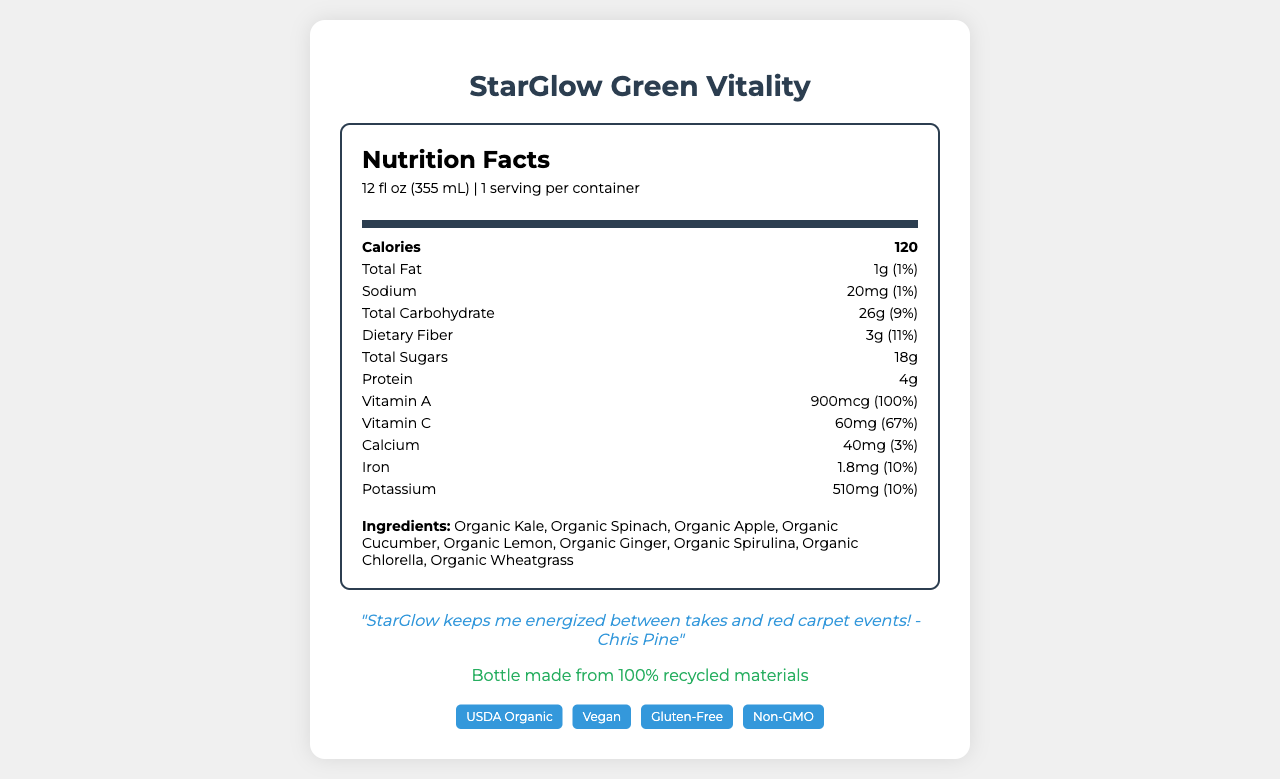how many calories are in one serving of StarGlow Green Vitality? The nutrition facts label lists the number of calories as 120 under the section for calories.
Answer: 120 calories what is the serving size of StarGlow Green Vitality? The serving size is indicated as "12 fl oz (355 mL)" above the calories section on the nutrition facts label.
Answer: 12 fl oz (355 mL) List three ingredients found in StarGlow Green Vitality. The ingredients are listed towards the bottom of the nutrition facts label, starting with Organic Kale, Organic Spinach, and Organic Apple.
Answer: Organic Kale, Organic Spinach, Organic Apple what percentage of daily vitamin C does StarGlow Green Vitality provide? The nutrition facts label shows that the juice provides 67% of the daily value of vitamin C.
Answer: 67% how much sodium is in one serving of StarGlow Green Vitality? The amount of sodium per serving is listed as 20mg on the nutrition facts label.
Answer: 20mg what is the dietary fiber content in StarGlow Green Vitality? The nutrition facts label indicates that there is 3 grams of dietary fiber in one serving.
Answer: 3g how many grams of protein are in StarGlow Green Vitality? The label states that the juice contains 4 grams of protein per serving.
Answer: 4g Which of the following certifications does StarGlow Green Vitality have? A. USDA Organic B. Fair Trade C. Halal The label includes a "USDA Organic" certification.
Answer: A. USDA Organic What is the daily value percentage of potassium in StarGlow Green Vitality? A. 5% B. 10% C. 15% D. 20% The label states that the daily value percentage of potassium is 10%.
Answer: B. 10% Is StarGlow Green Vitality vegan? The document mentions that the product is vegan, which is indicated in the certifications and labeled on the packaging.
Answer: Yes Summarize the main points of the StarGlow Green Vitality nutrition facts label. This summary covers the key nutritional values, ingredients, and certifications as displayed on the document.
Answer: StarGlow Green Vitality is a 12 fl oz premium bottled green juice containing 120 calories per serving. It is rich in vitamins A and C, providing 100% and 67% of daily values respectively, and offers 4g of protein. Key ingredients include organic kale, spinach, and apples. The juice is USDA Organic, vegan, gluten-free, non-GMO, and cold-pressed with no added sugars. Who is the celebrity endorsing StarGlow Green Vitality? The specific name of the celebrity endorsing the product isn’t listed in the document provided; however, there is a quote included from Chris Pine endorsing the product.
Answer: Not enough information 